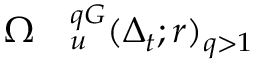Convert formula to latex. <formula><loc_0><loc_0><loc_500><loc_500>\begin{array} { r l } { \Omega } & _ { u } ^ { q G } ( \Delta _ { t } ; r ) _ { q > 1 } } \end{array}</formula> 